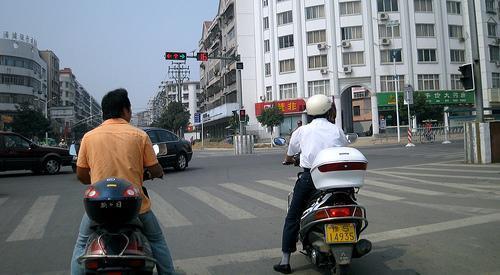How many people are riding mopeds in the photo?
Give a very brief answer. 2. How many numbers are on the yellow license plate?
Give a very brief answer. 5. 